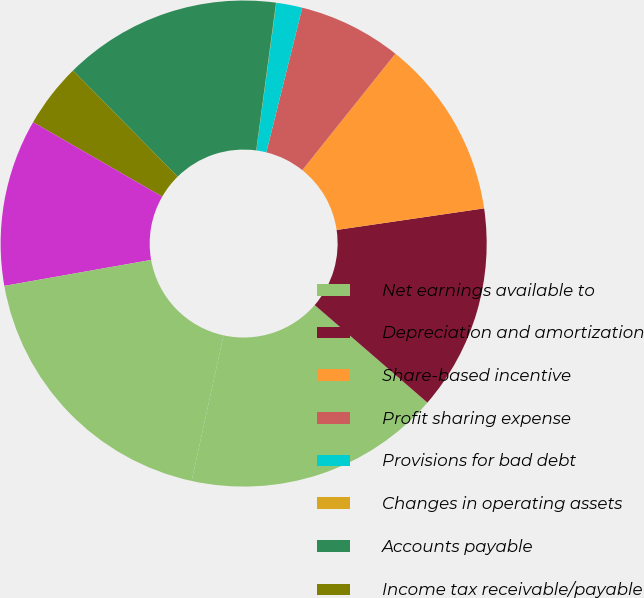Convert chart. <chart><loc_0><loc_0><loc_500><loc_500><pie_chart><fcel>Net earnings available to<fcel>Depreciation and amortization<fcel>Share-based incentive<fcel>Profit sharing expense<fcel>Provisions for bad debt<fcel>Changes in operating assets<fcel>Accounts payable<fcel>Income tax receivable/payable<fcel>Other assets and liabilities<fcel>Net cash provided by operating<nl><fcel>17.08%<fcel>13.67%<fcel>11.96%<fcel>6.85%<fcel>1.73%<fcel>0.02%<fcel>14.52%<fcel>4.29%<fcel>11.11%<fcel>18.78%<nl></chart> 